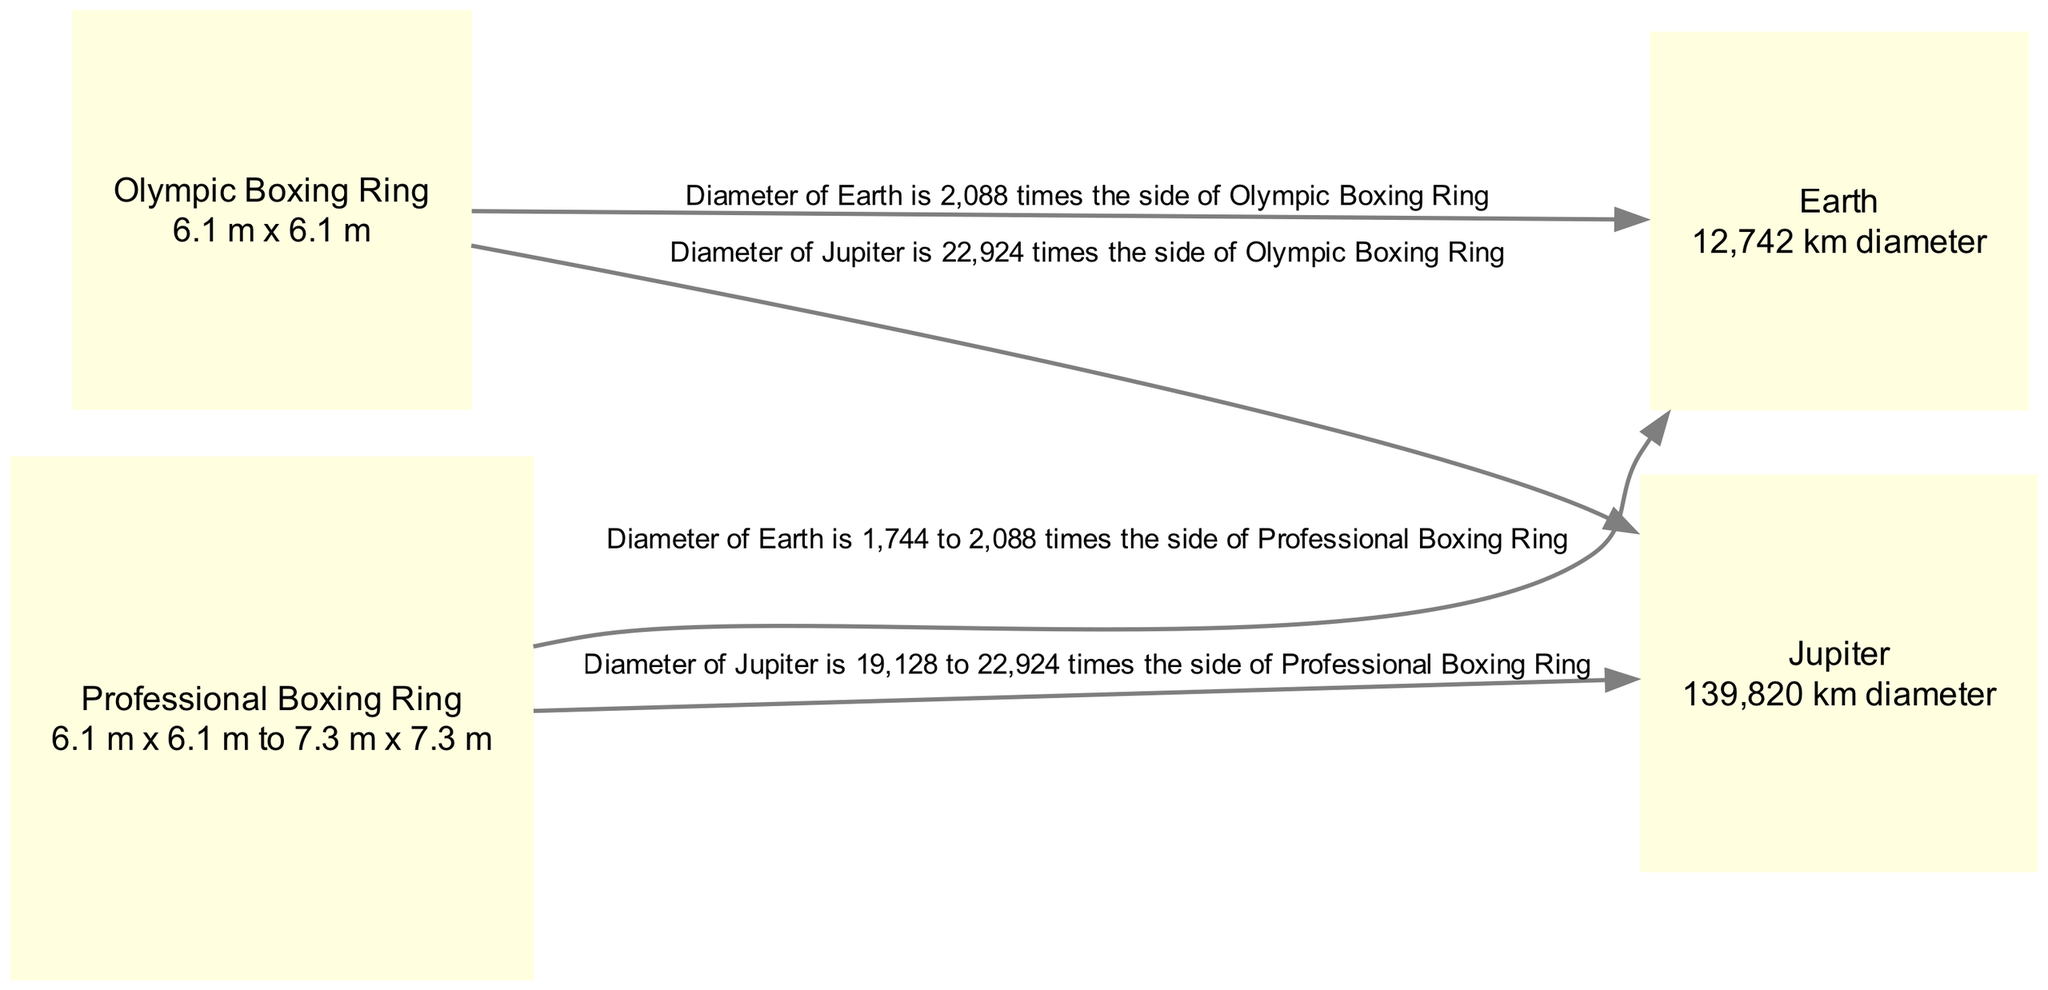What is the diameter of Earth? The diagram states that Earth's diameter is 12,742 km, which is explicitly mentioned in the node labeled "Earth."
Answer: 12,742 km How many times greater is the diameter of Earth compared to the Olympic Boxing Ring? The diagram shows that the diameter of Earth is 2,088 times the side of the Olympic Boxing Ring, as indicated by the edge connecting these two nodes.
Answer: 2,088 What is the diameter of Jupiter? The diagram states that Jupiter's diameter is 139,820 km, which is clearly labeled in the node labeled "Jupiter."
Answer: 139,820 km How many times greater is the diameter of Jupiter compared to the Olympic Boxing Ring? According to the diagram, the diameter of Jupiter is 22,924 times the side of the Olympic Boxing Ring, as indicated by the edge between these two nodes.
Answer: 22,924 What is the range of times the diameter of Earth is compared to the Professional Boxing Ring? The diagram indicates that the diameter of Earth is between 1,744 to 2,088 times the side of the Professional Boxing Ring, as shown in the edge connecting these nodes.
Answer: 1,744 to 2,088 What is the range of times the diameter of Jupiter is compared to the Professional Boxing Ring? The diagram shows that the diameter of Jupiter is between 19,128 to 22,924 times the side of the Professional Boxing Ring, as indicated in the edge connecting these two nodes.
Answer: 19,128 to 22,924 How many nodes are present in the diagram? The diagram features a total of four nodes: Earth, Jupiter, Olympic Boxing Ring, and Professional Boxing Ring. By counting them, we find there are four in total.
Answer: 4 What type of visual comparison does this diagram primarily represent? This diagram primarily represents a visual comparison of sizes between celestial bodies (planets) and sports equipment (boxing rings), shown through the dimensions of each.
Answer: Comparative sizes 